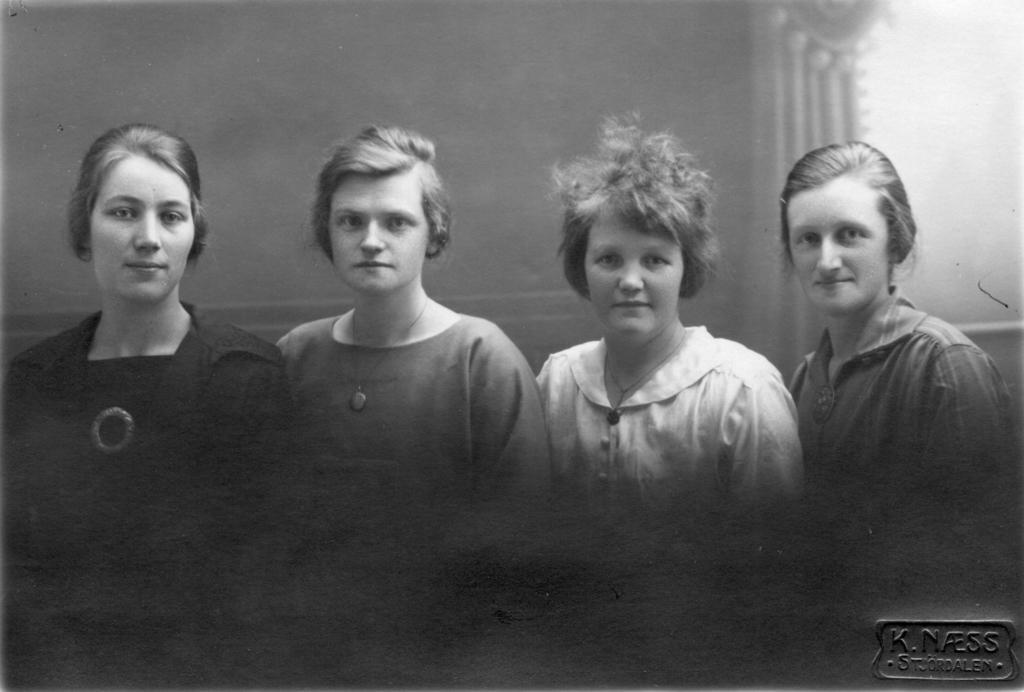How would you summarize this image in a sentence or two? This image looks like an edited photo, in which I can see four persons, text and a building. 